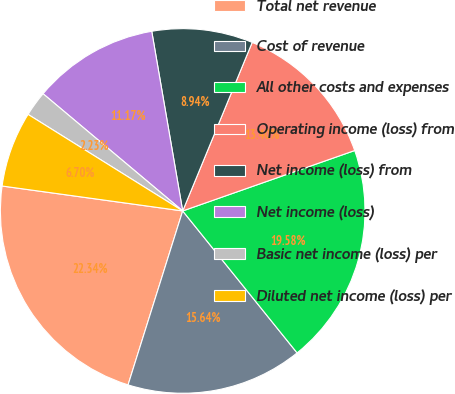Convert chart. <chart><loc_0><loc_0><loc_500><loc_500><pie_chart><fcel>Total net revenue<fcel>Cost of revenue<fcel>All other costs and expenses<fcel>Operating income (loss) from<fcel>Net income (loss) from<fcel>Net income (loss)<fcel>Basic net income (loss) per<fcel>Diluted net income (loss) per<nl><fcel>22.34%<fcel>15.64%<fcel>19.58%<fcel>13.4%<fcel>8.94%<fcel>11.17%<fcel>2.23%<fcel>6.7%<nl></chart> 